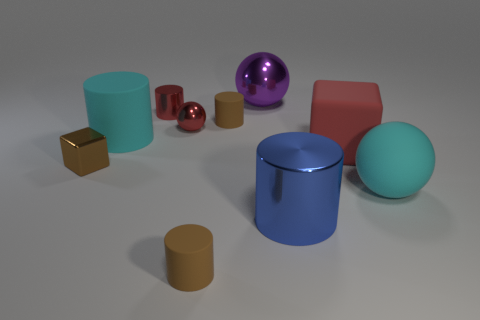Subtract all brown balls. How many brown cylinders are left? 2 Subtract all tiny red metal cylinders. How many cylinders are left? 4 Subtract all blue cylinders. How many cylinders are left? 4 Subtract all red cylinders. Subtract all green cubes. How many cylinders are left? 4 Subtract all cubes. How many objects are left? 8 Subtract all red cubes. Subtract all tiny metal spheres. How many objects are left? 8 Add 8 big purple metallic things. How many big purple metallic things are left? 9 Add 1 blue objects. How many blue objects exist? 2 Subtract 2 brown cylinders. How many objects are left? 8 